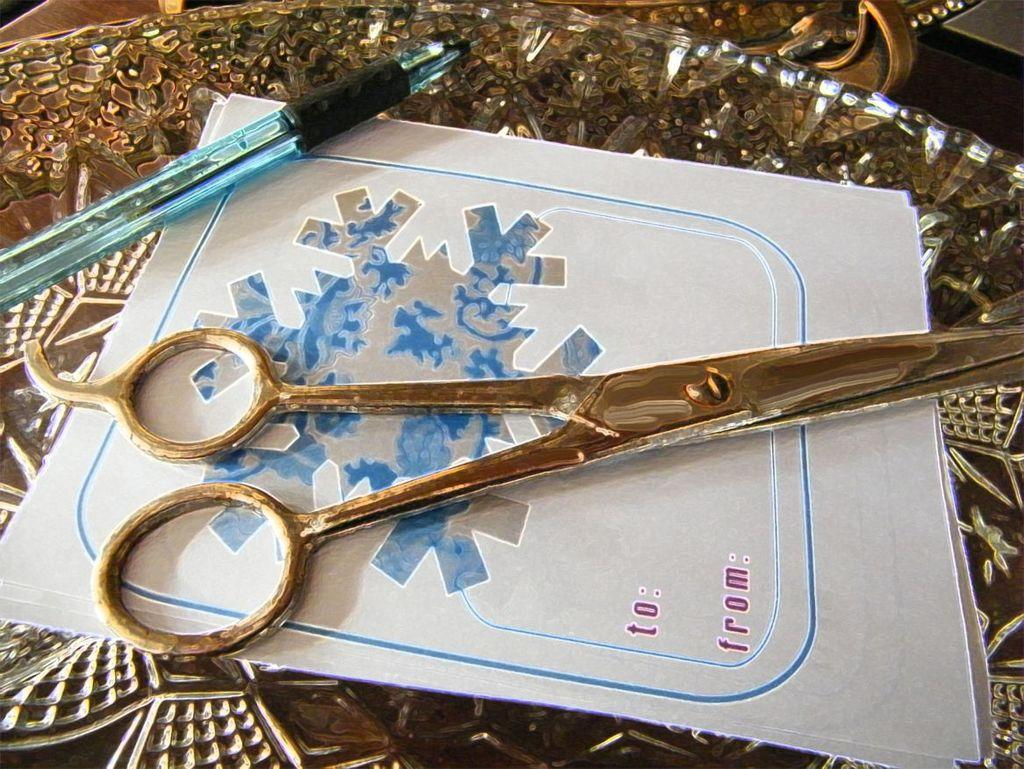What stationery item can be seen in the image? There is a pen in the image. What other object related to stationery can be seen in the image? There are scissors in the image. What type of paper item is present in the image? There is a card in the image. Where are all the objects located in the image? All objects are on a plate. What type of toothpaste is being used to sort the objects in the image? There is no toothpaste present in the image, and the objects are not being sorted. 